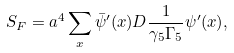<formula> <loc_0><loc_0><loc_500><loc_500>S _ { F } = a ^ { 4 } \sum _ { x } \bar { \psi } ^ { \prime } ( x ) D \frac { 1 } { \gamma _ { 5 } \Gamma _ { 5 } } \psi ^ { \prime } ( x ) ,</formula> 